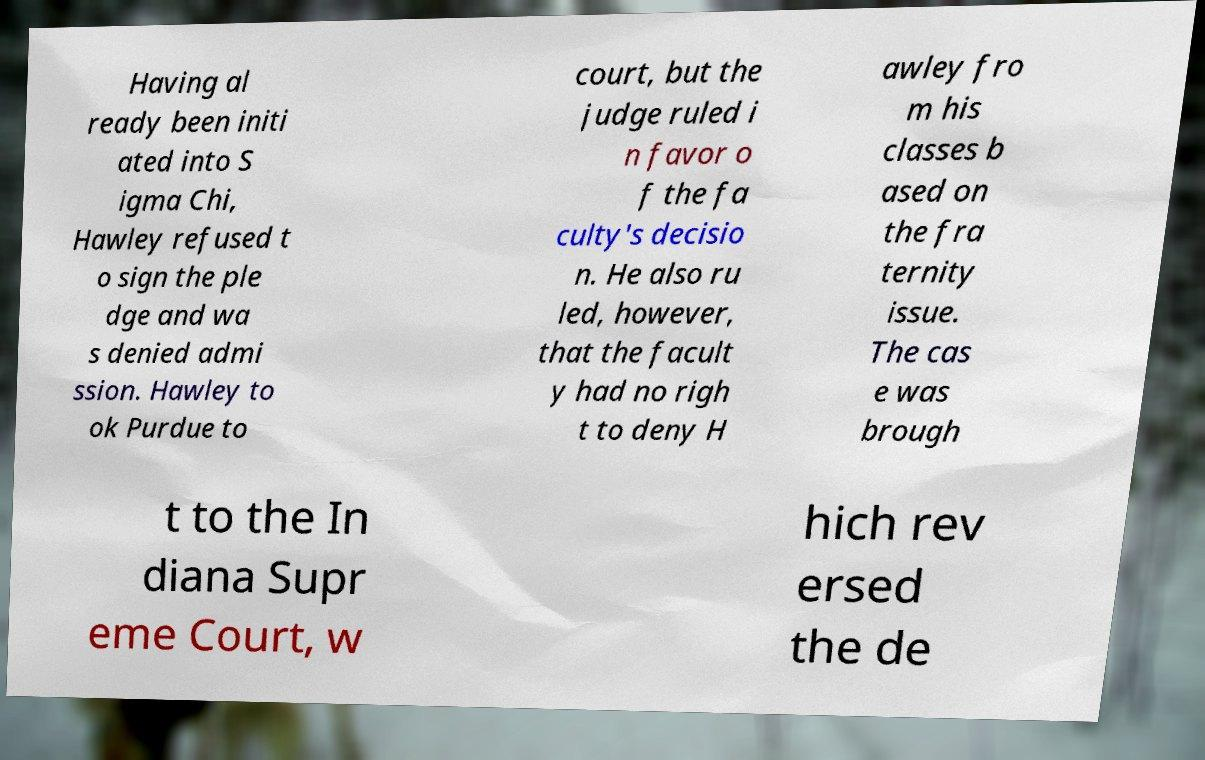There's text embedded in this image that I need extracted. Can you transcribe it verbatim? Having al ready been initi ated into S igma Chi, Hawley refused t o sign the ple dge and wa s denied admi ssion. Hawley to ok Purdue to court, but the judge ruled i n favor o f the fa culty's decisio n. He also ru led, however, that the facult y had no righ t to deny H awley fro m his classes b ased on the fra ternity issue. The cas e was brough t to the In diana Supr eme Court, w hich rev ersed the de 